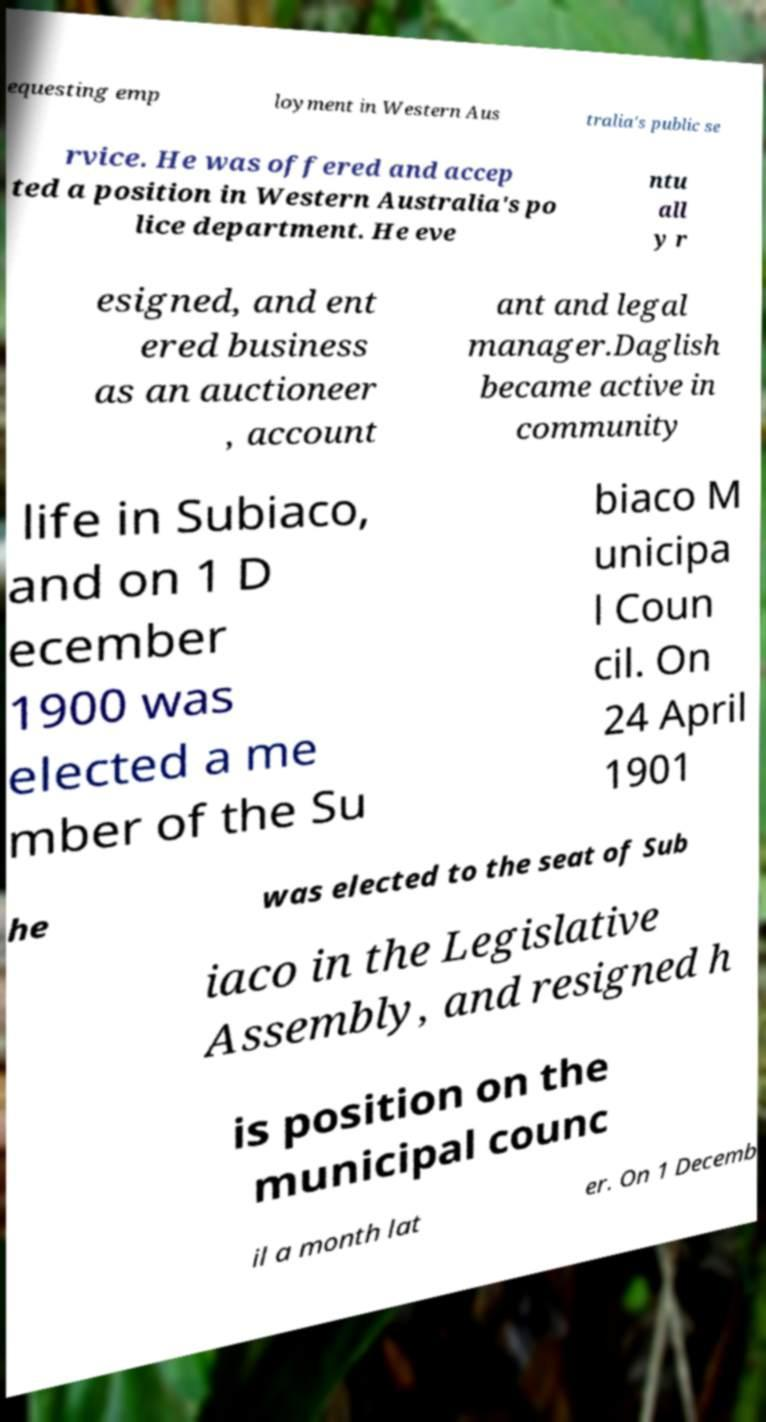Can you read and provide the text displayed in the image?This photo seems to have some interesting text. Can you extract and type it out for me? equesting emp loyment in Western Aus tralia's public se rvice. He was offered and accep ted a position in Western Australia's po lice department. He eve ntu all y r esigned, and ent ered business as an auctioneer , account ant and legal manager.Daglish became active in community life in Subiaco, and on 1 D ecember 1900 was elected a me mber of the Su biaco M unicipa l Coun cil. On 24 April 1901 he was elected to the seat of Sub iaco in the Legislative Assembly, and resigned h is position on the municipal counc il a month lat er. On 1 Decemb 